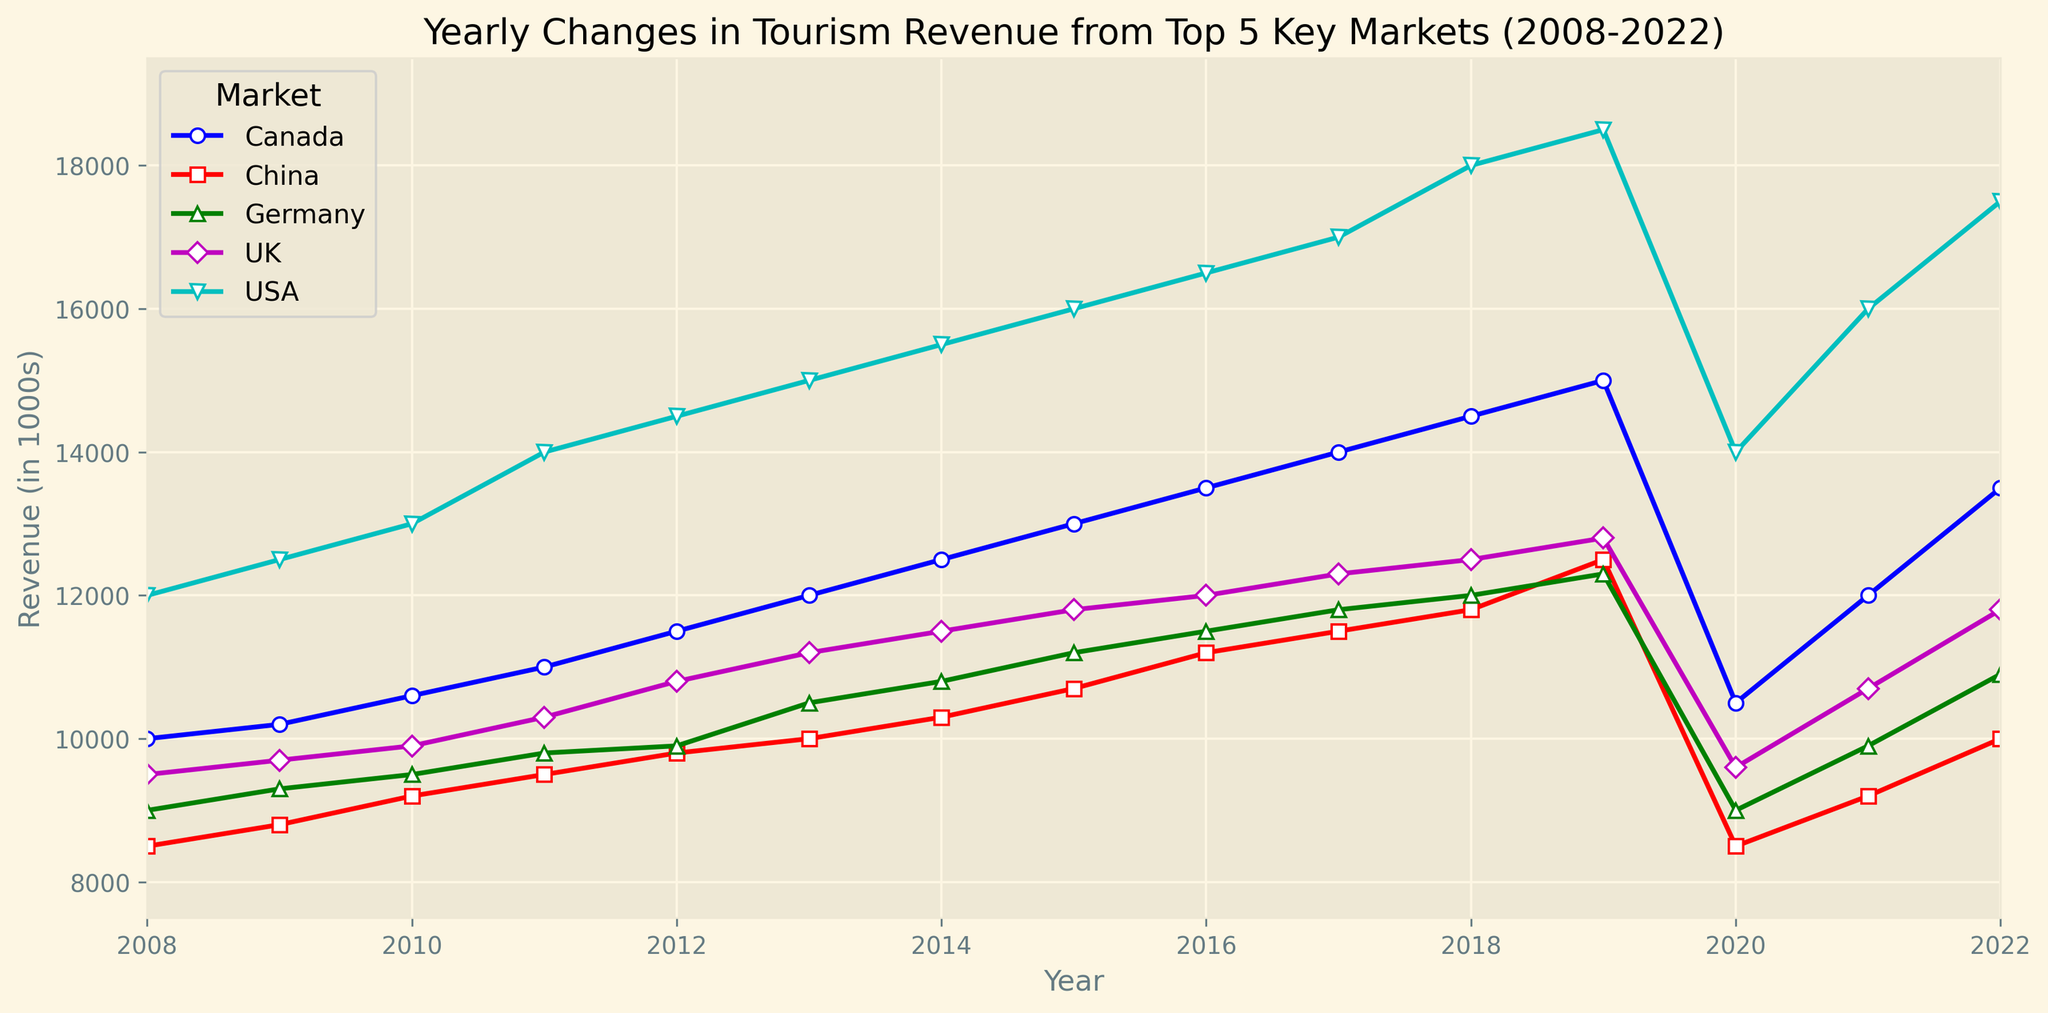What year saw the highest tourism revenue from the USA? The USA's revenue is highest when the corresponding value peaks on the line chart. By observing the plotted lines, the highest point for the USA corresponds to the year.
Answer: 2019 Which market had the lowest revenue in 2020? To determine this, compare the heights of the points for each market in the year 2020. The market with the lowest point on the chart for that year represents the lowest revenue.
Answer: China Between 2008 and 2022, which market showed the most consistent increase in revenue? Identify the market with the smoothest, steadily rising line from start to end. The market whose line consistently rises without sharp declines indicates the most consistent increase.
Answer: Canada What was the percent decrease in revenue for the USA from 2019 to 2020? First, find the revenue values for the USA in 2019 and 2020. Calculate the difference, and then divide by the 2019 value and multiply by 100 to get the percentage decrease.
Answer: 24.32% In which year did Germany surpass UK's revenue, and what was the difference? Find the year where Germany's line crosses above UK's line. Check the respective values for that year and calculate their difference.
Answer: 2019, 500 Which market saw the largest drop in tourism revenue in 2020? Look at the slope of the lines from 2019 to 2020 for each market. The steepest downward slope represents the largest drop in revenue.
Answer: USA In 2022, what is the combined revenue from Canada and China? Locate the points for Canada and China in 2022 on the chart, then sum these values.
Answer: 27500 What was the trend in tourism revenue for the UK between 2008 and 2022? Observe the UK line from 2008 to 2022 and describe the general pattern—whether it is rising, falling, or has fluctuations.
Answer: Mostly increasing Compare the highest and lowest revenue values for China during the period. What is the difference? Identify the peaks and troughs of China's line on the chart and subtract the lowest value from the highest.
Answer: 12500 - 8500 = 4000 What year did Canada first achieve a revenue of over 12000? Trace the Canada line to find the first point where it crosses the 12000 revenue mark.
Answer: 2013 